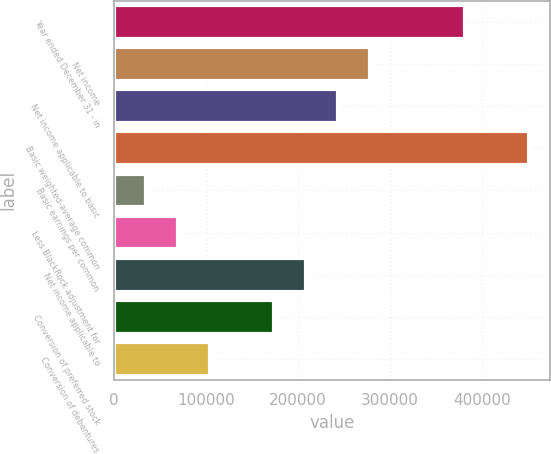Convert chart to OTSL. <chart><loc_0><loc_0><loc_500><loc_500><bar_chart><fcel>Year ended December 31 - in<fcel>Net income<fcel>Net income applicable to basic<fcel>Basic weighted-average common<fcel>Basic earnings per common<fcel>Less BlackRock adjustment for<fcel>Net income applicable to<fcel>Conversion of preferred stock<fcel>Conversion of debentures<nl><fcel>381772<fcel>277653<fcel>242947<fcel>451185<fcel>34708.8<fcel>69415.2<fcel>208241<fcel>173534<fcel>104122<nl></chart> 